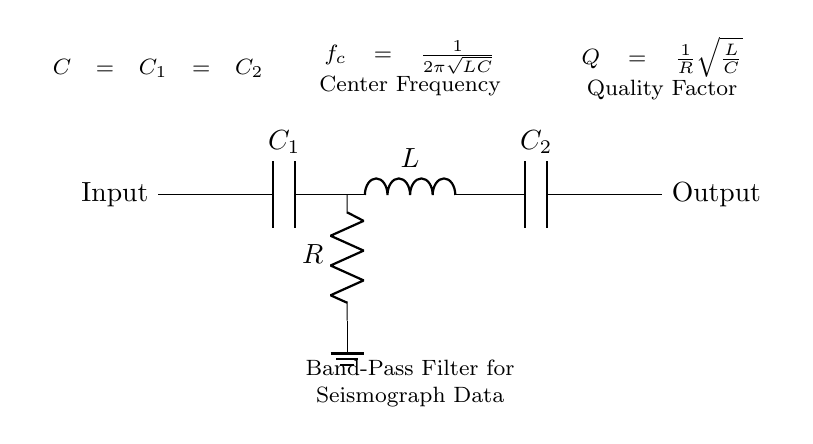What is the type of this circuit? This circuit is a band-pass filter, which is designed to allow a specific range of frequencies to pass through while attenuating frequencies outside that range. This is inferred from the arrangement of the capacitors and inductor, which is characteristic of band-pass filter configurations.
Answer: band-pass filter What are the components in this circuit? The components labeled in the circuit are two capacitors (C1 and C2), one inductor (L), and one resistor (R). These components are standard in a band-pass filter setup and are used to create the desired frequency response.
Answer: C1, C2, L, R What is the center frequency formula for this filter? The center frequency formula is given as f_c = 1/(2π√(LC)) and provides the frequency at which the filter is most effective at passing signal. It is based on the values of the inductor and capacitor in the circuit, as indicated in the diagram.
Answer: f_c = 1/(2π√(LC)) What is the quality factor of this filter? The quality factor (Q) of the filter is expressed as Q = 1/R√(L/C), which reflects how selective the filter is regarding its center frequency. It depends on the resistance (R), inductance (L), and capacitance (C) values in the circuit.
Answer: Q = 1/R√(L/C) How many capacitors are present in this circuit? There are two capacitors present in the circuit labeled as C1 and C2. The diagram explicitly indicates the presence of both, which contribute to the filter's characteristics.
Answer: 2 What happens to frequencies outside the passband? Frequencies outside the passband are attenuated, meaning they experience a reduction in amplitude as they do not meet the criteria set by the components of the circuit. This is a fundamental property of band-pass filters, which are designed to isolate specific frequency ranges.
Answer: Attenuated What is the role of the resistor in this circuit? The resistor in the circuit plays a key role in determining the quality factor (Q) of the band-pass filter. It influences how much of the signal's amplitude is retained at the center frequency, thus impacting the filter's effectiveness in selecting frequencies.
Answer: Determine quality factor 